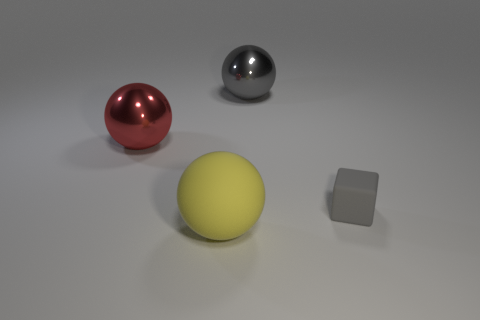Add 1 large red balls. How many objects exist? 5 Subtract all cubes. How many objects are left? 3 Add 4 big gray things. How many big gray things are left? 5 Add 3 gray spheres. How many gray spheres exist? 4 Subtract 0 purple balls. How many objects are left? 4 Subtract all big matte spheres. Subtract all tiny gray rubber things. How many objects are left? 2 